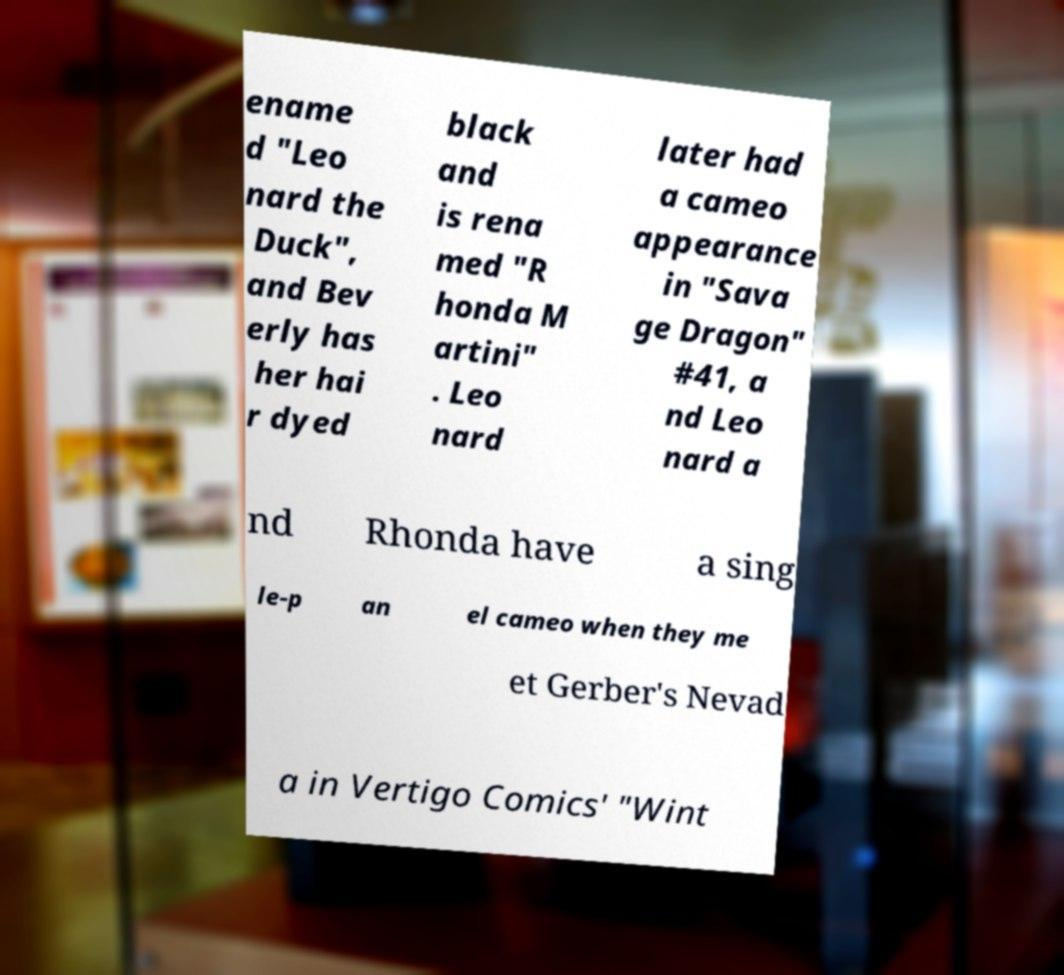What messages or text are displayed in this image? I need them in a readable, typed format. ename d "Leo nard the Duck", and Bev erly has her hai r dyed black and is rena med "R honda M artini" . Leo nard later had a cameo appearance in "Sava ge Dragon" #41, a nd Leo nard a nd Rhonda have a sing le-p an el cameo when they me et Gerber's Nevad a in Vertigo Comics' "Wint 